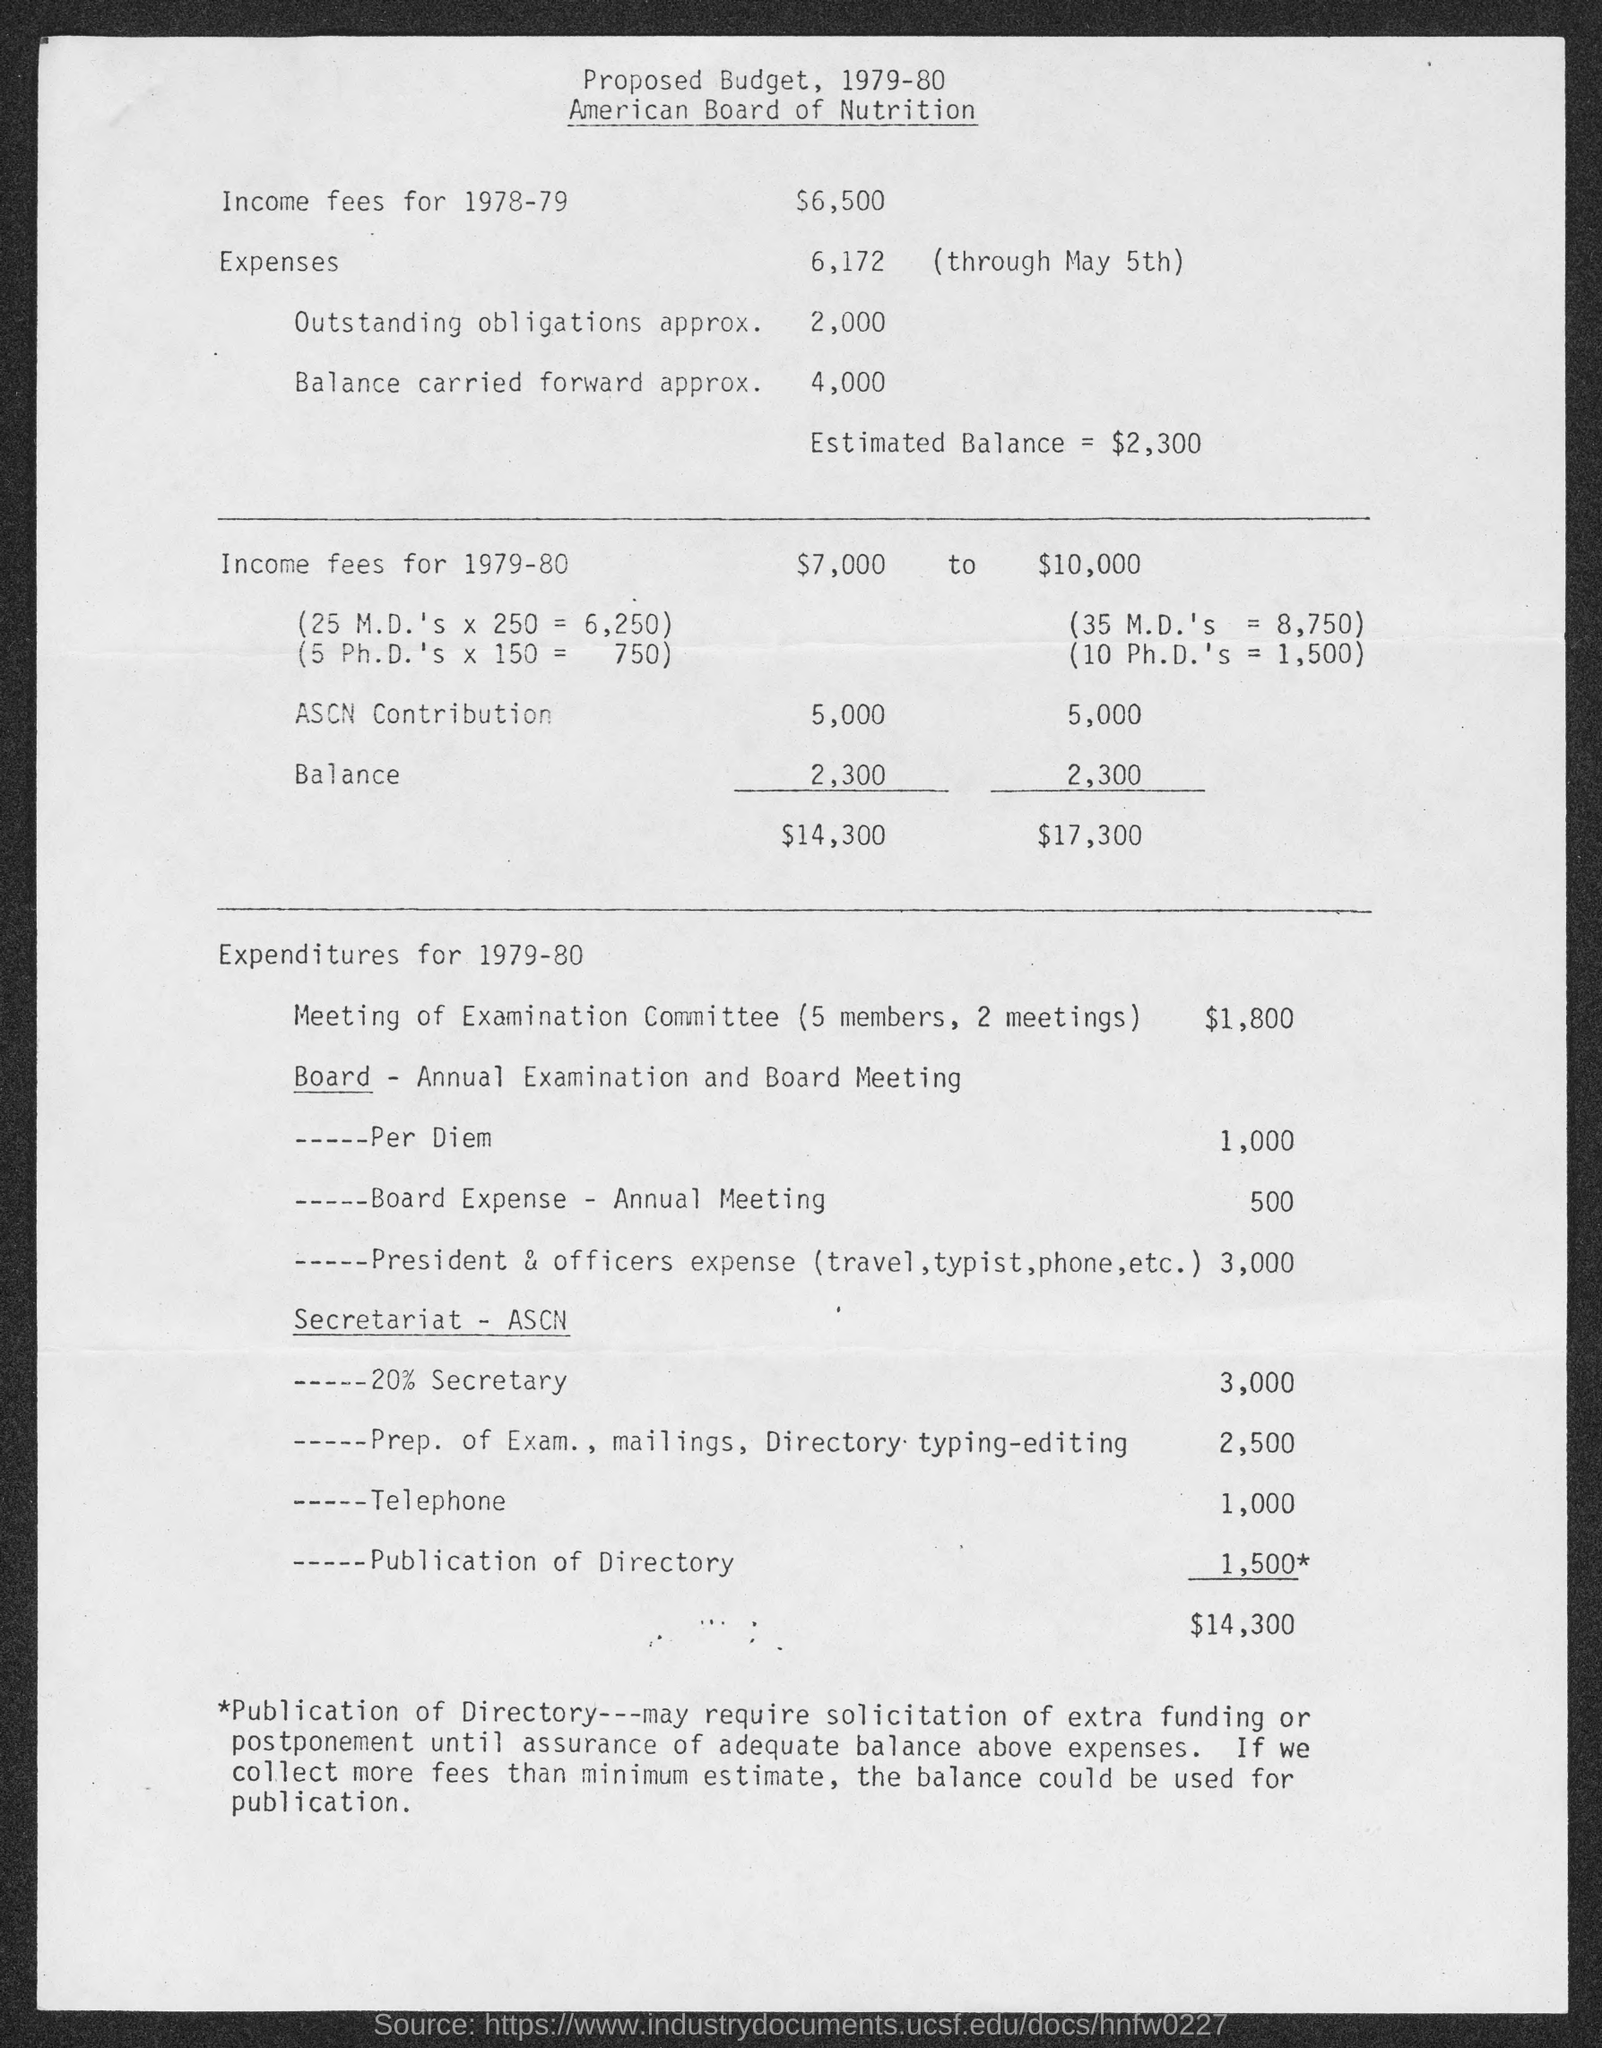What is the proposed budget for the income fees for 1978-79?
Make the answer very short. $6,500. What is the proposed budget for the income fees for 1979-80?
Give a very brief answer. $7000     to      $10,000. What is the proposed budget for Meeting of Examination Committee (5 members, 2 meetings)?
Provide a succinct answer. $1,800. What is the proposed budget for total Expenditure for 1979-80?
Your answer should be very brief. $14,300. 